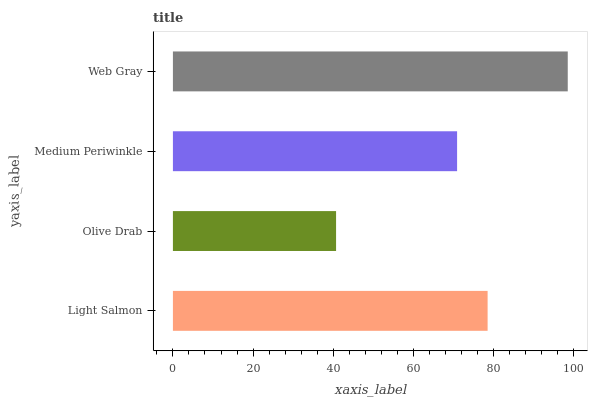Is Olive Drab the minimum?
Answer yes or no. Yes. Is Web Gray the maximum?
Answer yes or no. Yes. Is Medium Periwinkle the minimum?
Answer yes or no. No. Is Medium Periwinkle the maximum?
Answer yes or no. No. Is Medium Periwinkle greater than Olive Drab?
Answer yes or no. Yes. Is Olive Drab less than Medium Periwinkle?
Answer yes or no. Yes. Is Olive Drab greater than Medium Periwinkle?
Answer yes or no. No. Is Medium Periwinkle less than Olive Drab?
Answer yes or no. No. Is Light Salmon the high median?
Answer yes or no. Yes. Is Medium Periwinkle the low median?
Answer yes or no. Yes. Is Medium Periwinkle the high median?
Answer yes or no. No. Is Olive Drab the low median?
Answer yes or no. No. 